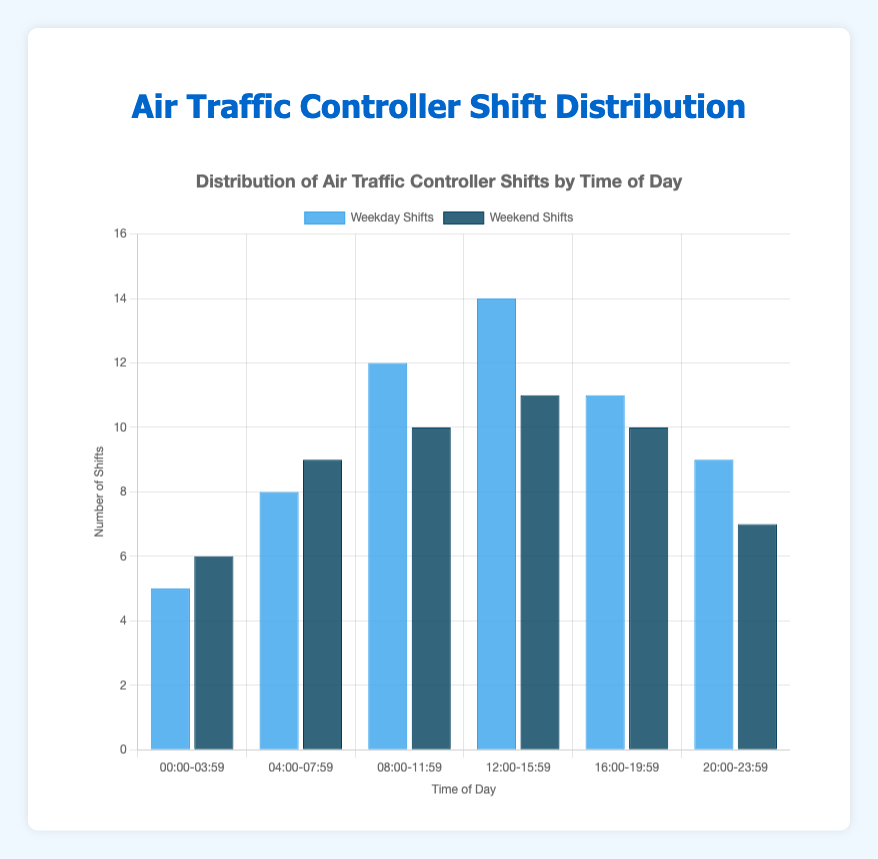What is the total number of weekday shifts from 16:00-19:59 and weekend shifts from 12:00-15:59? The number of weekday shifts from 16:00-19:59 is 11, and the number of weekend shifts from 12:00-15:59 is 11. Adding these together, 11 + 11 = 22.
Answer: 22 Which time range has a higher number of weekend shifts compared to its corresponding weekday shifts? For the 00:00-03:59 time range, weekend shifts (6) are higher than weekday shifts (5).
Answer: 00:00-03:59 Which bar is taller: the weekday shifts for 08:00-11:59 or the weekend shifts for 08:00-11:59? The bar for weekday shifts during 08:00-11:59 is taller (12 shifts) compared to the weekend shifts during the same period (10 shifts).
Answer: Weekday shifts for 08:00-11:59 What is the average number of shifts for the time ranges 08:00-11:59 and 12:00-15:59 combined, considering only the weekday shifts? The number of weekday shifts for 08:00-11:59 is 12 and for 12:00-15:59 is 14. The average is (12 + 14) / 2 = 26 / 2 = 13.
Answer: 13 For which time ranges are the number of weekday and weekend shifts equal? None of the time ranges have an equal number of weekday and weekend shifts.
Answer: None How many more shifts are there on weekdays from 12:00-15:59 compared to weekends from 20:00-23:59? Weekday shifts from 12:00-15:59 are 14 and weekend shifts from 20:00-23:59 are 7. The difference is 14 - 7 = 7.
Answer: 7 What time range has the highest number of weekend shifts and how many are there? The time range 04:00-07:59 has the highest number of weekend shifts with 9 shifts.
Answer: 04:00-07:59, 9 shifts Do the weekday shifts in the 20:00-23:59 range have more shifts than the weekend shifts in the same range? Yes, the weekday shifts in the 20:00-23:59 range have 9 shifts, compared to 7 shifts on the weekend.
Answer: Yes What is the combined total number of shifts for both weekdays and weekends for the time range 04:00-07:59? The number of weekday shifts for 04:00-07:59 is 8 and the weekend shifts are 9. The total is 8 + 9 = 17.
Answer: 17 